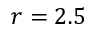<formula> <loc_0><loc_0><loc_500><loc_500>r = 2 . 5</formula> 